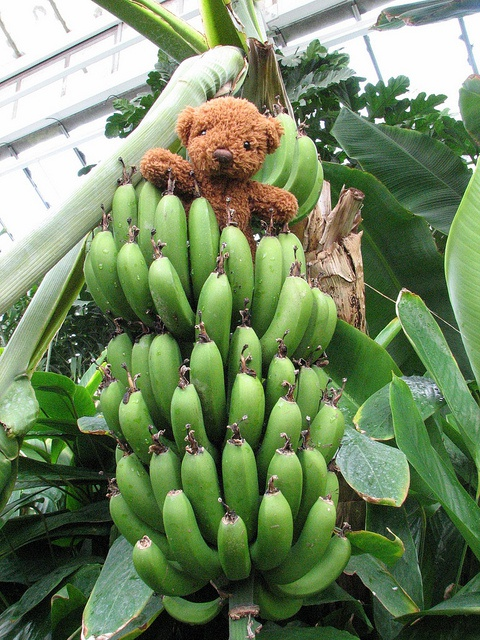Describe the objects in this image and their specific colors. I can see banana in white, darkgreen, black, and green tones, teddy bear in white, tan, maroon, and brown tones, and banana in white, lightgreen, olive, and khaki tones in this image. 